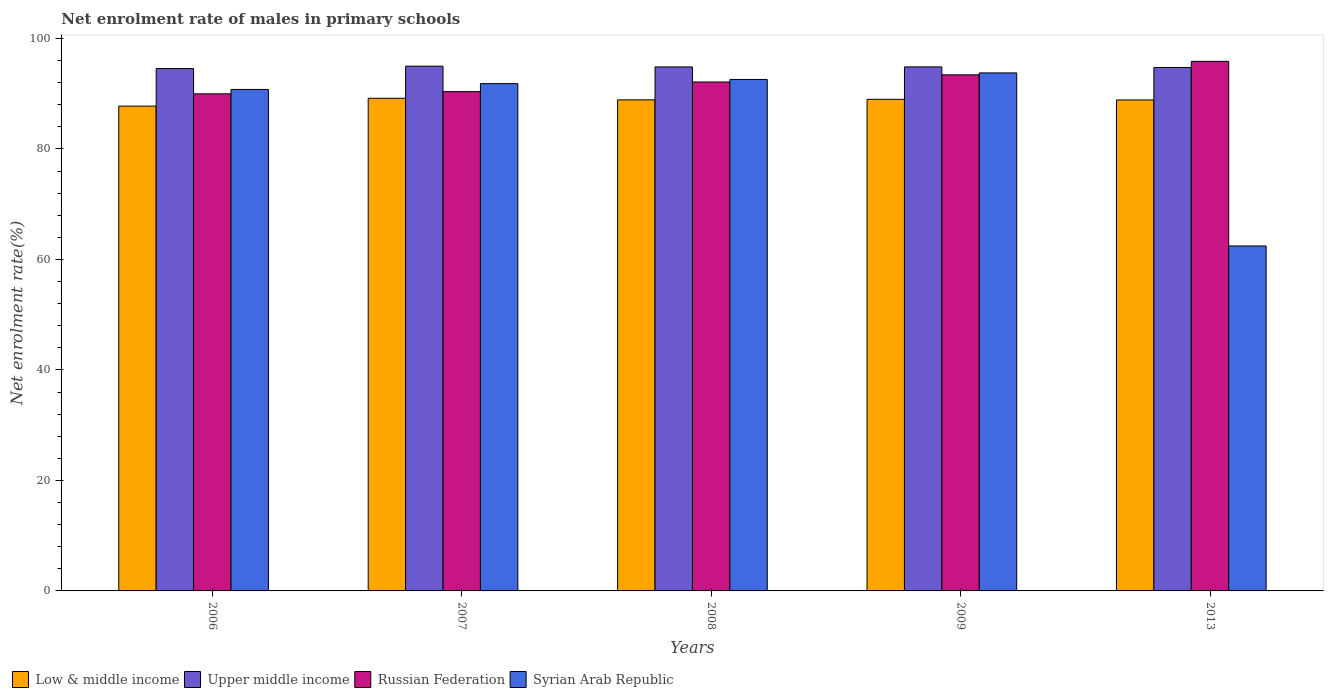How many different coloured bars are there?
Offer a very short reply. 4. Are the number of bars on each tick of the X-axis equal?
Give a very brief answer. Yes. How many bars are there on the 4th tick from the left?
Offer a very short reply. 4. How many bars are there on the 5th tick from the right?
Your response must be concise. 4. In how many cases, is the number of bars for a given year not equal to the number of legend labels?
Offer a terse response. 0. What is the net enrolment rate of males in primary schools in Low & middle income in 2008?
Your answer should be very brief. 88.89. Across all years, what is the maximum net enrolment rate of males in primary schools in Low & middle income?
Keep it short and to the point. 89.18. Across all years, what is the minimum net enrolment rate of males in primary schools in Russian Federation?
Ensure brevity in your answer.  89.98. In which year was the net enrolment rate of males in primary schools in Russian Federation minimum?
Provide a succinct answer. 2006. What is the total net enrolment rate of males in primary schools in Syrian Arab Republic in the graph?
Your answer should be compact. 431.42. What is the difference between the net enrolment rate of males in primary schools in Low & middle income in 2006 and that in 2009?
Offer a very short reply. -1.23. What is the difference between the net enrolment rate of males in primary schools in Russian Federation in 2009 and the net enrolment rate of males in primary schools in Upper middle income in 2013?
Give a very brief answer. -1.32. What is the average net enrolment rate of males in primary schools in Low & middle income per year?
Give a very brief answer. 88.74. In the year 2008, what is the difference between the net enrolment rate of males in primary schools in Syrian Arab Republic and net enrolment rate of males in primary schools in Low & middle income?
Keep it short and to the point. 3.7. In how many years, is the net enrolment rate of males in primary schools in Upper middle income greater than 28 %?
Give a very brief answer. 5. What is the ratio of the net enrolment rate of males in primary schools in Russian Federation in 2007 to that in 2013?
Your answer should be compact. 0.94. Is the net enrolment rate of males in primary schools in Syrian Arab Republic in 2006 less than that in 2008?
Offer a very short reply. Yes. What is the difference between the highest and the second highest net enrolment rate of males in primary schools in Syrian Arab Republic?
Provide a short and direct response. 1.18. What is the difference between the highest and the lowest net enrolment rate of males in primary schools in Low & middle income?
Offer a very short reply. 1.42. In how many years, is the net enrolment rate of males in primary schools in Upper middle income greater than the average net enrolment rate of males in primary schools in Upper middle income taken over all years?
Offer a terse response. 3. Is the sum of the net enrolment rate of males in primary schools in Low & middle income in 2009 and 2013 greater than the maximum net enrolment rate of males in primary schools in Syrian Arab Republic across all years?
Give a very brief answer. Yes. Is it the case that in every year, the sum of the net enrolment rate of males in primary schools in Russian Federation and net enrolment rate of males in primary schools in Upper middle income is greater than the sum of net enrolment rate of males in primary schools in Low & middle income and net enrolment rate of males in primary schools in Syrian Arab Republic?
Your response must be concise. Yes. What does the 3rd bar from the left in 2007 represents?
Keep it short and to the point. Russian Federation. What does the 2nd bar from the right in 2013 represents?
Give a very brief answer. Russian Federation. Is it the case that in every year, the sum of the net enrolment rate of males in primary schools in Low & middle income and net enrolment rate of males in primary schools in Syrian Arab Republic is greater than the net enrolment rate of males in primary schools in Upper middle income?
Ensure brevity in your answer.  Yes. How many bars are there?
Give a very brief answer. 20. Are all the bars in the graph horizontal?
Offer a very short reply. No. What is the difference between two consecutive major ticks on the Y-axis?
Offer a very short reply. 20. Are the values on the major ticks of Y-axis written in scientific E-notation?
Your response must be concise. No. Does the graph contain grids?
Offer a terse response. No. Where does the legend appear in the graph?
Offer a terse response. Bottom left. How many legend labels are there?
Provide a short and direct response. 4. What is the title of the graph?
Your response must be concise. Net enrolment rate of males in primary schools. Does "Guinea" appear as one of the legend labels in the graph?
Your answer should be compact. No. What is the label or title of the X-axis?
Ensure brevity in your answer.  Years. What is the label or title of the Y-axis?
Make the answer very short. Net enrolment rate(%). What is the Net enrolment rate(%) in Low & middle income in 2006?
Make the answer very short. 87.76. What is the Net enrolment rate(%) of Upper middle income in 2006?
Make the answer very short. 94.56. What is the Net enrolment rate(%) of Russian Federation in 2006?
Your response must be concise. 89.98. What is the Net enrolment rate(%) in Syrian Arab Republic in 2006?
Your answer should be compact. 90.78. What is the Net enrolment rate(%) in Low & middle income in 2007?
Ensure brevity in your answer.  89.18. What is the Net enrolment rate(%) of Upper middle income in 2007?
Provide a succinct answer. 94.99. What is the Net enrolment rate(%) of Russian Federation in 2007?
Offer a terse response. 90.39. What is the Net enrolment rate(%) of Syrian Arab Republic in 2007?
Provide a succinct answer. 91.83. What is the Net enrolment rate(%) of Low & middle income in 2008?
Ensure brevity in your answer.  88.89. What is the Net enrolment rate(%) in Upper middle income in 2008?
Your answer should be compact. 94.85. What is the Net enrolment rate(%) of Russian Federation in 2008?
Provide a succinct answer. 92.13. What is the Net enrolment rate(%) of Syrian Arab Republic in 2008?
Your answer should be very brief. 92.59. What is the Net enrolment rate(%) of Low & middle income in 2009?
Make the answer very short. 88.99. What is the Net enrolment rate(%) in Upper middle income in 2009?
Keep it short and to the point. 94.86. What is the Net enrolment rate(%) in Russian Federation in 2009?
Your response must be concise. 93.43. What is the Net enrolment rate(%) of Syrian Arab Republic in 2009?
Keep it short and to the point. 93.77. What is the Net enrolment rate(%) of Low & middle income in 2013?
Provide a short and direct response. 88.87. What is the Net enrolment rate(%) in Upper middle income in 2013?
Your answer should be very brief. 94.75. What is the Net enrolment rate(%) of Russian Federation in 2013?
Give a very brief answer. 95.86. What is the Net enrolment rate(%) in Syrian Arab Republic in 2013?
Offer a very short reply. 62.45. Across all years, what is the maximum Net enrolment rate(%) in Low & middle income?
Provide a succinct answer. 89.18. Across all years, what is the maximum Net enrolment rate(%) in Upper middle income?
Provide a succinct answer. 94.99. Across all years, what is the maximum Net enrolment rate(%) of Russian Federation?
Offer a terse response. 95.86. Across all years, what is the maximum Net enrolment rate(%) of Syrian Arab Republic?
Provide a succinct answer. 93.77. Across all years, what is the minimum Net enrolment rate(%) in Low & middle income?
Provide a short and direct response. 87.76. Across all years, what is the minimum Net enrolment rate(%) in Upper middle income?
Offer a terse response. 94.56. Across all years, what is the minimum Net enrolment rate(%) of Russian Federation?
Your response must be concise. 89.98. Across all years, what is the minimum Net enrolment rate(%) in Syrian Arab Republic?
Ensure brevity in your answer.  62.45. What is the total Net enrolment rate(%) of Low & middle income in the graph?
Give a very brief answer. 443.69. What is the total Net enrolment rate(%) in Upper middle income in the graph?
Provide a short and direct response. 474.01. What is the total Net enrolment rate(%) in Russian Federation in the graph?
Provide a succinct answer. 461.78. What is the total Net enrolment rate(%) in Syrian Arab Republic in the graph?
Ensure brevity in your answer.  431.42. What is the difference between the Net enrolment rate(%) of Low & middle income in 2006 and that in 2007?
Your answer should be compact. -1.42. What is the difference between the Net enrolment rate(%) in Upper middle income in 2006 and that in 2007?
Offer a terse response. -0.43. What is the difference between the Net enrolment rate(%) of Russian Federation in 2006 and that in 2007?
Make the answer very short. -0.4. What is the difference between the Net enrolment rate(%) in Syrian Arab Republic in 2006 and that in 2007?
Give a very brief answer. -1.05. What is the difference between the Net enrolment rate(%) of Low & middle income in 2006 and that in 2008?
Keep it short and to the point. -1.13. What is the difference between the Net enrolment rate(%) in Upper middle income in 2006 and that in 2008?
Make the answer very short. -0.29. What is the difference between the Net enrolment rate(%) in Russian Federation in 2006 and that in 2008?
Provide a short and direct response. -2.15. What is the difference between the Net enrolment rate(%) in Syrian Arab Republic in 2006 and that in 2008?
Keep it short and to the point. -1.81. What is the difference between the Net enrolment rate(%) of Low & middle income in 2006 and that in 2009?
Your answer should be compact. -1.23. What is the difference between the Net enrolment rate(%) in Upper middle income in 2006 and that in 2009?
Ensure brevity in your answer.  -0.3. What is the difference between the Net enrolment rate(%) of Russian Federation in 2006 and that in 2009?
Give a very brief answer. -3.45. What is the difference between the Net enrolment rate(%) of Syrian Arab Republic in 2006 and that in 2009?
Offer a very short reply. -2.99. What is the difference between the Net enrolment rate(%) in Low & middle income in 2006 and that in 2013?
Offer a terse response. -1.11. What is the difference between the Net enrolment rate(%) in Upper middle income in 2006 and that in 2013?
Make the answer very short. -0.19. What is the difference between the Net enrolment rate(%) in Russian Federation in 2006 and that in 2013?
Give a very brief answer. -5.88. What is the difference between the Net enrolment rate(%) in Syrian Arab Republic in 2006 and that in 2013?
Provide a succinct answer. 28.33. What is the difference between the Net enrolment rate(%) in Low & middle income in 2007 and that in 2008?
Give a very brief answer. 0.29. What is the difference between the Net enrolment rate(%) of Upper middle income in 2007 and that in 2008?
Your answer should be compact. 0.14. What is the difference between the Net enrolment rate(%) of Russian Federation in 2007 and that in 2008?
Make the answer very short. -1.74. What is the difference between the Net enrolment rate(%) of Syrian Arab Republic in 2007 and that in 2008?
Your answer should be very brief. -0.76. What is the difference between the Net enrolment rate(%) in Low & middle income in 2007 and that in 2009?
Ensure brevity in your answer.  0.19. What is the difference between the Net enrolment rate(%) in Upper middle income in 2007 and that in 2009?
Make the answer very short. 0.13. What is the difference between the Net enrolment rate(%) in Russian Federation in 2007 and that in 2009?
Your response must be concise. -3.04. What is the difference between the Net enrolment rate(%) of Syrian Arab Republic in 2007 and that in 2009?
Provide a succinct answer. -1.94. What is the difference between the Net enrolment rate(%) in Low & middle income in 2007 and that in 2013?
Ensure brevity in your answer.  0.31. What is the difference between the Net enrolment rate(%) of Upper middle income in 2007 and that in 2013?
Ensure brevity in your answer.  0.24. What is the difference between the Net enrolment rate(%) of Russian Federation in 2007 and that in 2013?
Your answer should be very brief. -5.48. What is the difference between the Net enrolment rate(%) in Syrian Arab Republic in 2007 and that in 2013?
Your response must be concise. 29.39. What is the difference between the Net enrolment rate(%) of Low & middle income in 2008 and that in 2009?
Your answer should be very brief. -0.1. What is the difference between the Net enrolment rate(%) of Upper middle income in 2008 and that in 2009?
Provide a succinct answer. -0.01. What is the difference between the Net enrolment rate(%) of Russian Federation in 2008 and that in 2009?
Your response must be concise. -1.3. What is the difference between the Net enrolment rate(%) in Syrian Arab Republic in 2008 and that in 2009?
Keep it short and to the point. -1.18. What is the difference between the Net enrolment rate(%) in Low & middle income in 2008 and that in 2013?
Offer a very short reply. 0.02. What is the difference between the Net enrolment rate(%) of Upper middle income in 2008 and that in 2013?
Ensure brevity in your answer.  0.1. What is the difference between the Net enrolment rate(%) of Russian Federation in 2008 and that in 2013?
Your response must be concise. -3.73. What is the difference between the Net enrolment rate(%) in Syrian Arab Republic in 2008 and that in 2013?
Keep it short and to the point. 30.14. What is the difference between the Net enrolment rate(%) of Low & middle income in 2009 and that in 2013?
Offer a very short reply. 0.11. What is the difference between the Net enrolment rate(%) of Upper middle income in 2009 and that in 2013?
Your response must be concise. 0.11. What is the difference between the Net enrolment rate(%) of Russian Federation in 2009 and that in 2013?
Your response must be concise. -2.43. What is the difference between the Net enrolment rate(%) of Syrian Arab Republic in 2009 and that in 2013?
Give a very brief answer. 31.32. What is the difference between the Net enrolment rate(%) in Low & middle income in 2006 and the Net enrolment rate(%) in Upper middle income in 2007?
Make the answer very short. -7.23. What is the difference between the Net enrolment rate(%) in Low & middle income in 2006 and the Net enrolment rate(%) in Russian Federation in 2007?
Give a very brief answer. -2.63. What is the difference between the Net enrolment rate(%) of Low & middle income in 2006 and the Net enrolment rate(%) of Syrian Arab Republic in 2007?
Your response must be concise. -4.07. What is the difference between the Net enrolment rate(%) in Upper middle income in 2006 and the Net enrolment rate(%) in Russian Federation in 2007?
Provide a succinct answer. 4.17. What is the difference between the Net enrolment rate(%) in Upper middle income in 2006 and the Net enrolment rate(%) in Syrian Arab Republic in 2007?
Your answer should be compact. 2.73. What is the difference between the Net enrolment rate(%) of Russian Federation in 2006 and the Net enrolment rate(%) of Syrian Arab Republic in 2007?
Provide a succinct answer. -1.85. What is the difference between the Net enrolment rate(%) in Low & middle income in 2006 and the Net enrolment rate(%) in Upper middle income in 2008?
Make the answer very short. -7.09. What is the difference between the Net enrolment rate(%) in Low & middle income in 2006 and the Net enrolment rate(%) in Russian Federation in 2008?
Give a very brief answer. -4.37. What is the difference between the Net enrolment rate(%) in Low & middle income in 2006 and the Net enrolment rate(%) in Syrian Arab Republic in 2008?
Your response must be concise. -4.83. What is the difference between the Net enrolment rate(%) of Upper middle income in 2006 and the Net enrolment rate(%) of Russian Federation in 2008?
Your answer should be very brief. 2.43. What is the difference between the Net enrolment rate(%) of Upper middle income in 2006 and the Net enrolment rate(%) of Syrian Arab Republic in 2008?
Keep it short and to the point. 1.97. What is the difference between the Net enrolment rate(%) in Russian Federation in 2006 and the Net enrolment rate(%) in Syrian Arab Republic in 2008?
Your response must be concise. -2.61. What is the difference between the Net enrolment rate(%) of Low & middle income in 2006 and the Net enrolment rate(%) of Upper middle income in 2009?
Ensure brevity in your answer.  -7.1. What is the difference between the Net enrolment rate(%) in Low & middle income in 2006 and the Net enrolment rate(%) in Russian Federation in 2009?
Give a very brief answer. -5.67. What is the difference between the Net enrolment rate(%) in Low & middle income in 2006 and the Net enrolment rate(%) in Syrian Arab Republic in 2009?
Provide a short and direct response. -6.01. What is the difference between the Net enrolment rate(%) in Upper middle income in 2006 and the Net enrolment rate(%) in Russian Federation in 2009?
Keep it short and to the point. 1.13. What is the difference between the Net enrolment rate(%) of Upper middle income in 2006 and the Net enrolment rate(%) of Syrian Arab Republic in 2009?
Offer a terse response. 0.79. What is the difference between the Net enrolment rate(%) of Russian Federation in 2006 and the Net enrolment rate(%) of Syrian Arab Republic in 2009?
Your answer should be compact. -3.79. What is the difference between the Net enrolment rate(%) of Low & middle income in 2006 and the Net enrolment rate(%) of Upper middle income in 2013?
Your answer should be very brief. -6.99. What is the difference between the Net enrolment rate(%) of Low & middle income in 2006 and the Net enrolment rate(%) of Russian Federation in 2013?
Give a very brief answer. -8.1. What is the difference between the Net enrolment rate(%) of Low & middle income in 2006 and the Net enrolment rate(%) of Syrian Arab Republic in 2013?
Your answer should be very brief. 25.31. What is the difference between the Net enrolment rate(%) in Upper middle income in 2006 and the Net enrolment rate(%) in Russian Federation in 2013?
Ensure brevity in your answer.  -1.3. What is the difference between the Net enrolment rate(%) in Upper middle income in 2006 and the Net enrolment rate(%) in Syrian Arab Republic in 2013?
Make the answer very short. 32.11. What is the difference between the Net enrolment rate(%) in Russian Federation in 2006 and the Net enrolment rate(%) in Syrian Arab Republic in 2013?
Keep it short and to the point. 27.54. What is the difference between the Net enrolment rate(%) of Low & middle income in 2007 and the Net enrolment rate(%) of Upper middle income in 2008?
Your response must be concise. -5.67. What is the difference between the Net enrolment rate(%) of Low & middle income in 2007 and the Net enrolment rate(%) of Russian Federation in 2008?
Your response must be concise. -2.95. What is the difference between the Net enrolment rate(%) of Low & middle income in 2007 and the Net enrolment rate(%) of Syrian Arab Republic in 2008?
Provide a succinct answer. -3.41. What is the difference between the Net enrolment rate(%) in Upper middle income in 2007 and the Net enrolment rate(%) in Russian Federation in 2008?
Make the answer very short. 2.86. What is the difference between the Net enrolment rate(%) of Upper middle income in 2007 and the Net enrolment rate(%) of Syrian Arab Republic in 2008?
Keep it short and to the point. 2.4. What is the difference between the Net enrolment rate(%) in Russian Federation in 2007 and the Net enrolment rate(%) in Syrian Arab Republic in 2008?
Offer a very short reply. -2.2. What is the difference between the Net enrolment rate(%) of Low & middle income in 2007 and the Net enrolment rate(%) of Upper middle income in 2009?
Ensure brevity in your answer.  -5.68. What is the difference between the Net enrolment rate(%) of Low & middle income in 2007 and the Net enrolment rate(%) of Russian Federation in 2009?
Offer a terse response. -4.25. What is the difference between the Net enrolment rate(%) in Low & middle income in 2007 and the Net enrolment rate(%) in Syrian Arab Republic in 2009?
Make the answer very short. -4.59. What is the difference between the Net enrolment rate(%) in Upper middle income in 2007 and the Net enrolment rate(%) in Russian Federation in 2009?
Offer a terse response. 1.56. What is the difference between the Net enrolment rate(%) in Upper middle income in 2007 and the Net enrolment rate(%) in Syrian Arab Republic in 2009?
Give a very brief answer. 1.22. What is the difference between the Net enrolment rate(%) of Russian Federation in 2007 and the Net enrolment rate(%) of Syrian Arab Republic in 2009?
Give a very brief answer. -3.39. What is the difference between the Net enrolment rate(%) of Low & middle income in 2007 and the Net enrolment rate(%) of Upper middle income in 2013?
Give a very brief answer. -5.57. What is the difference between the Net enrolment rate(%) of Low & middle income in 2007 and the Net enrolment rate(%) of Russian Federation in 2013?
Your answer should be very brief. -6.68. What is the difference between the Net enrolment rate(%) in Low & middle income in 2007 and the Net enrolment rate(%) in Syrian Arab Republic in 2013?
Keep it short and to the point. 26.73. What is the difference between the Net enrolment rate(%) in Upper middle income in 2007 and the Net enrolment rate(%) in Russian Federation in 2013?
Offer a very short reply. -0.87. What is the difference between the Net enrolment rate(%) of Upper middle income in 2007 and the Net enrolment rate(%) of Syrian Arab Republic in 2013?
Your answer should be very brief. 32.54. What is the difference between the Net enrolment rate(%) of Russian Federation in 2007 and the Net enrolment rate(%) of Syrian Arab Republic in 2013?
Offer a terse response. 27.94. What is the difference between the Net enrolment rate(%) of Low & middle income in 2008 and the Net enrolment rate(%) of Upper middle income in 2009?
Your response must be concise. -5.97. What is the difference between the Net enrolment rate(%) in Low & middle income in 2008 and the Net enrolment rate(%) in Russian Federation in 2009?
Keep it short and to the point. -4.54. What is the difference between the Net enrolment rate(%) of Low & middle income in 2008 and the Net enrolment rate(%) of Syrian Arab Republic in 2009?
Ensure brevity in your answer.  -4.88. What is the difference between the Net enrolment rate(%) in Upper middle income in 2008 and the Net enrolment rate(%) in Russian Federation in 2009?
Ensure brevity in your answer.  1.43. What is the difference between the Net enrolment rate(%) of Upper middle income in 2008 and the Net enrolment rate(%) of Syrian Arab Republic in 2009?
Provide a succinct answer. 1.08. What is the difference between the Net enrolment rate(%) of Russian Federation in 2008 and the Net enrolment rate(%) of Syrian Arab Republic in 2009?
Provide a succinct answer. -1.64. What is the difference between the Net enrolment rate(%) of Low & middle income in 2008 and the Net enrolment rate(%) of Upper middle income in 2013?
Keep it short and to the point. -5.86. What is the difference between the Net enrolment rate(%) of Low & middle income in 2008 and the Net enrolment rate(%) of Russian Federation in 2013?
Your answer should be compact. -6.97. What is the difference between the Net enrolment rate(%) in Low & middle income in 2008 and the Net enrolment rate(%) in Syrian Arab Republic in 2013?
Your answer should be very brief. 26.45. What is the difference between the Net enrolment rate(%) of Upper middle income in 2008 and the Net enrolment rate(%) of Russian Federation in 2013?
Your answer should be compact. -1.01. What is the difference between the Net enrolment rate(%) of Upper middle income in 2008 and the Net enrolment rate(%) of Syrian Arab Republic in 2013?
Provide a succinct answer. 32.41. What is the difference between the Net enrolment rate(%) of Russian Federation in 2008 and the Net enrolment rate(%) of Syrian Arab Republic in 2013?
Keep it short and to the point. 29.68. What is the difference between the Net enrolment rate(%) of Low & middle income in 2009 and the Net enrolment rate(%) of Upper middle income in 2013?
Provide a short and direct response. -5.76. What is the difference between the Net enrolment rate(%) in Low & middle income in 2009 and the Net enrolment rate(%) in Russian Federation in 2013?
Offer a very short reply. -6.87. What is the difference between the Net enrolment rate(%) in Low & middle income in 2009 and the Net enrolment rate(%) in Syrian Arab Republic in 2013?
Make the answer very short. 26.54. What is the difference between the Net enrolment rate(%) in Upper middle income in 2009 and the Net enrolment rate(%) in Russian Federation in 2013?
Ensure brevity in your answer.  -1. What is the difference between the Net enrolment rate(%) in Upper middle income in 2009 and the Net enrolment rate(%) in Syrian Arab Republic in 2013?
Offer a terse response. 32.41. What is the difference between the Net enrolment rate(%) of Russian Federation in 2009 and the Net enrolment rate(%) of Syrian Arab Republic in 2013?
Offer a terse response. 30.98. What is the average Net enrolment rate(%) in Low & middle income per year?
Your answer should be compact. 88.74. What is the average Net enrolment rate(%) of Upper middle income per year?
Keep it short and to the point. 94.8. What is the average Net enrolment rate(%) in Russian Federation per year?
Keep it short and to the point. 92.36. What is the average Net enrolment rate(%) in Syrian Arab Republic per year?
Provide a succinct answer. 86.28. In the year 2006, what is the difference between the Net enrolment rate(%) in Low & middle income and Net enrolment rate(%) in Upper middle income?
Keep it short and to the point. -6.8. In the year 2006, what is the difference between the Net enrolment rate(%) in Low & middle income and Net enrolment rate(%) in Russian Federation?
Your answer should be very brief. -2.22. In the year 2006, what is the difference between the Net enrolment rate(%) in Low & middle income and Net enrolment rate(%) in Syrian Arab Republic?
Keep it short and to the point. -3.02. In the year 2006, what is the difference between the Net enrolment rate(%) of Upper middle income and Net enrolment rate(%) of Russian Federation?
Your answer should be very brief. 4.58. In the year 2006, what is the difference between the Net enrolment rate(%) of Upper middle income and Net enrolment rate(%) of Syrian Arab Republic?
Your answer should be compact. 3.78. In the year 2006, what is the difference between the Net enrolment rate(%) in Russian Federation and Net enrolment rate(%) in Syrian Arab Republic?
Provide a short and direct response. -0.8. In the year 2007, what is the difference between the Net enrolment rate(%) in Low & middle income and Net enrolment rate(%) in Upper middle income?
Offer a very short reply. -5.81. In the year 2007, what is the difference between the Net enrolment rate(%) in Low & middle income and Net enrolment rate(%) in Russian Federation?
Provide a short and direct response. -1.21. In the year 2007, what is the difference between the Net enrolment rate(%) of Low & middle income and Net enrolment rate(%) of Syrian Arab Republic?
Provide a short and direct response. -2.65. In the year 2007, what is the difference between the Net enrolment rate(%) of Upper middle income and Net enrolment rate(%) of Russian Federation?
Your answer should be very brief. 4.6. In the year 2007, what is the difference between the Net enrolment rate(%) of Upper middle income and Net enrolment rate(%) of Syrian Arab Republic?
Offer a very short reply. 3.16. In the year 2007, what is the difference between the Net enrolment rate(%) of Russian Federation and Net enrolment rate(%) of Syrian Arab Republic?
Provide a succinct answer. -1.45. In the year 2008, what is the difference between the Net enrolment rate(%) in Low & middle income and Net enrolment rate(%) in Upper middle income?
Make the answer very short. -5.96. In the year 2008, what is the difference between the Net enrolment rate(%) of Low & middle income and Net enrolment rate(%) of Russian Federation?
Offer a terse response. -3.23. In the year 2008, what is the difference between the Net enrolment rate(%) in Low & middle income and Net enrolment rate(%) in Syrian Arab Republic?
Make the answer very short. -3.7. In the year 2008, what is the difference between the Net enrolment rate(%) in Upper middle income and Net enrolment rate(%) in Russian Federation?
Your answer should be very brief. 2.73. In the year 2008, what is the difference between the Net enrolment rate(%) of Upper middle income and Net enrolment rate(%) of Syrian Arab Republic?
Your answer should be very brief. 2.27. In the year 2008, what is the difference between the Net enrolment rate(%) in Russian Federation and Net enrolment rate(%) in Syrian Arab Republic?
Provide a succinct answer. -0.46. In the year 2009, what is the difference between the Net enrolment rate(%) in Low & middle income and Net enrolment rate(%) in Upper middle income?
Make the answer very short. -5.87. In the year 2009, what is the difference between the Net enrolment rate(%) in Low & middle income and Net enrolment rate(%) in Russian Federation?
Make the answer very short. -4.44. In the year 2009, what is the difference between the Net enrolment rate(%) of Low & middle income and Net enrolment rate(%) of Syrian Arab Republic?
Provide a succinct answer. -4.78. In the year 2009, what is the difference between the Net enrolment rate(%) in Upper middle income and Net enrolment rate(%) in Russian Federation?
Offer a very short reply. 1.43. In the year 2009, what is the difference between the Net enrolment rate(%) in Upper middle income and Net enrolment rate(%) in Syrian Arab Republic?
Provide a short and direct response. 1.09. In the year 2009, what is the difference between the Net enrolment rate(%) in Russian Federation and Net enrolment rate(%) in Syrian Arab Republic?
Make the answer very short. -0.34. In the year 2013, what is the difference between the Net enrolment rate(%) of Low & middle income and Net enrolment rate(%) of Upper middle income?
Offer a terse response. -5.88. In the year 2013, what is the difference between the Net enrolment rate(%) of Low & middle income and Net enrolment rate(%) of Russian Federation?
Your answer should be compact. -6.99. In the year 2013, what is the difference between the Net enrolment rate(%) of Low & middle income and Net enrolment rate(%) of Syrian Arab Republic?
Make the answer very short. 26.43. In the year 2013, what is the difference between the Net enrolment rate(%) of Upper middle income and Net enrolment rate(%) of Russian Federation?
Offer a very short reply. -1.11. In the year 2013, what is the difference between the Net enrolment rate(%) of Upper middle income and Net enrolment rate(%) of Syrian Arab Republic?
Your answer should be compact. 32.3. In the year 2013, what is the difference between the Net enrolment rate(%) in Russian Federation and Net enrolment rate(%) in Syrian Arab Republic?
Your response must be concise. 33.42. What is the ratio of the Net enrolment rate(%) in Low & middle income in 2006 to that in 2007?
Give a very brief answer. 0.98. What is the ratio of the Net enrolment rate(%) of Russian Federation in 2006 to that in 2007?
Your response must be concise. 1. What is the ratio of the Net enrolment rate(%) in Low & middle income in 2006 to that in 2008?
Keep it short and to the point. 0.99. What is the ratio of the Net enrolment rate(%) in Upper middle income in 2006 to that in 2008?
Your response must be concise. 1. What is the ratio of the Net enrolment rate(%) of Russian Federation in 2006 to that in 2008?
Your response must be concise. 0.98. What is the ratio of the Net enrolment rate(%) in Syrian Arab Republic in 2006 to that in 2008?
Provide a short and direct response. 0.98. What is the ratio of the Net enrolment rate(%) in Low & middle income in 2006 to that in 2009?
Give a very brief answer. 0.99. What is the ratio of the Net enrolment rate(%) of Upper middle income in 2006 to that in 2009?
Provide a succinct answer. 1. What is the ratio of the Net enrolment rate(%) in Russian Federation in 2006 to that in 2009?
Make the answer very short. 0.96. What is the ratio of the Net enrolment rate(%) in Syrian Arab Republic in 2006 to that in 2009?
Give a very brief answer. 0.97. What is the ratio of the Net enrolment rate(%) of Low & middle income in 2006 to that in 2013?
Your answer should be very brief. 0.99. What is the ratio of the Net enrolment rate(%) of Upper middle income in 2006 to that in 2013?
Offer a very short reply. 1. What is the ratio of the Net enrolment rate(%) of Russian Federation in 2006 to that in 2013?
Your response must be concise. 0.94. What is the ratio of the Net enrolment rate(%) in Syrian Arab Republic in 2006 to that in 2013?
Ensure brevity in your answer.  1.45. What is the ratio of the Net enrolment rate(%) of Low & middle income in 2007 to that in 2008?
Your answer should be very brief. 1. What is the ratio of the Net enrolment rate(%) of Russian Federation in 2007 to that in 2008?
Provide a short and direct response. 0.98. What is the ratio of the Net enrolment rate(%) of Syrian Arab Republic in 2007 to that in 2008?
Your answer should be very brief. 0.99. What is the ratio of the Net enrolment rate(%) of Low & middle income in 2007 to that in 2009?
Keep it short and to the point. 1. What is the ratio of the Net enrolment rate(%) of Russian Federation in 2007 to that in 2009?
Give a very brief answer. 0.97. What is the ratio of the Net enrolment rate(%) in Syrian Arab Republic in 2007 to that in 2009?
Give a very brief answer. 0.98. What is the ratio of the Net enrolment rate(%) in Low & middle income in 2007 to that in 2013?
Provide a succinct answer. 1. What is the ratio of the Net enrolment rate(%) of Upper middle income in 2007 to that in 2013?
Your answer should be very brief. 1. What is the ratio of the Net enrolment rate(%) in Russian Federation in 2007 to that in 2013?
Make the answer very short. 0.94. What is the ratio of the Net enrolment rate(%) of Syrian Arab Republic in 2007 to that in 2013?
Your answer should be compact. 1.47. What is the ratio of the Net enrolment rate(%) of Low & middle income in 2008 to that in 2009?
Offer a very short reply. 1. What is the ratio of the Net enrolment rate(%) of Russian Federation in 2008 to that in 2009?
Provide a short and direct response. 0.99. What is the ratio of the Net enrolment rate(%) in Syrian Arab Republic in 2008 to that in 2009?
Give a very brief answer. 0.99. What is the ratio of the Net enrolment rate(%) of Low & middle income in 2008 to that in 2013?
Make the answer very short. 1. What is the ratio of the Net enrolment rate(%) of Upper middle income in 2008 to that in 2013?
Your answer should be very brief. 1. What is the ratio of the Net enrolment rate(%) of Russian Federation in 2008 to that in 2013?
Make the answer very short. 0.96. What is the ratio of the Net enrolment rate(%) of Syrian Arab Republic in 2008 to that in 2013?
Your answer should be compact. 1.48. What is the ratio of the Net enrolment rate(%) in Low & middle income in 2009 to that in 2013?
Ensure brevity in your answer.  1. What is the ratio of the Net enrolment rate(%) of Russian Federation in 2009 to that in 2013?
Make the answer very short. 0.97. What is the ratio of the Net enrolment rate(%) in Syrian Arab Republic in 2009 to that in 2013?
Give a very brief answer. 1.5. What is the difference between the highest and the second highest Net enrolment rate(%) of Low & middle income?
Provide a short and direct response. 0.19. What is the difference between the highest and the second highest Net enrolment rate(%) in Upper middle income?
Your response must be concise. 0.13. What is the difference between the highest and the second highest Net enrolment rate(%) in Russian Federation?
Provide a succinct answer. 2.43. What is the difference between the highest and the second highest Net enrolment rate(%) of Syrian Arab Republic?
Ensure brevity in your answer.  1.18. What is the difference between the highest and the lowest Net enrolment rate(%) in Low & middle income?
Your answer should be compact. 1.42. What is the difference between the highest and the lowest Net enrolment rate(%) of Upper middle income?
Ensure brevity in your answer.  0.43. What is the difference between the highest and the lowest Net enrolment rate(%) of Russian Federation?
Your answer should be compact. 5.88. What is the difference between the highest and the lowest Net enrolment rate(%) in Syrian Arab Republic?
Your response must be concise. 31.32. 